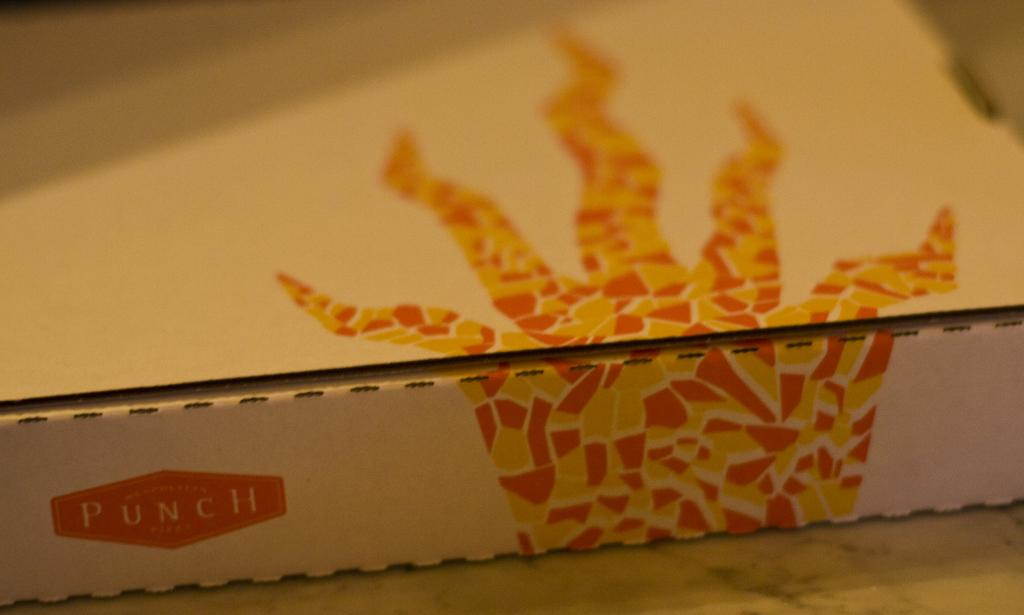<image>
Give a short and clear explanation of the subsequent image. Punch is written on the side of this cardboard box. 